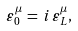<formula> <loc_0><loc_0><loc_500><loc_500>\varepsilon _ { 0 } ^ { \mu } \, = \, i \, \varepsilon _ { L } ^ { \mu } ,</formula> 